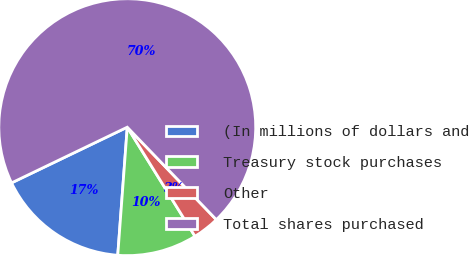Convert chart. <chart><loc_0><loc_0><loc_500><loc_500><pie_chart><fcel>(In millions of dollars and<fcel>Treasury stock purchases<fcel>Other<fcel>Total shares purchased<nl><fcel>16.68%<fcel>10.02%<fcel>3.36%<fcel>69.94%<nl></chart> 